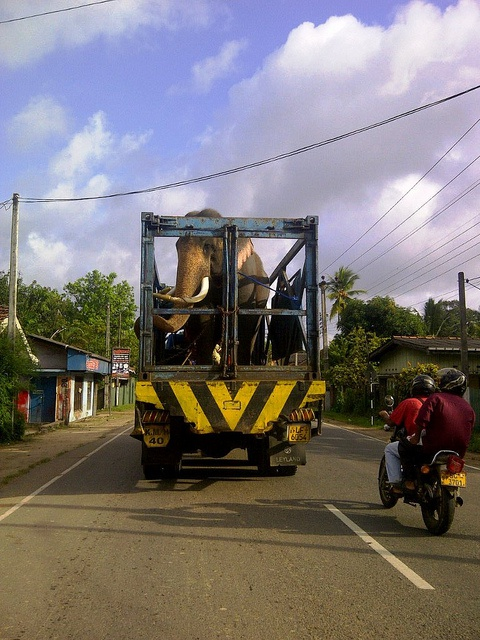Describe the objects in this image and their specific colors. I can see truck in darkgray, black, gray, and olive tones, elephant in darkgray, black, maroon, and gray tones, people in darkgray, black, maroon, gray, and darkgreen tones, motorcycle in darkgray, black, maroon, olive, and gray tones, and people in darkgray, black, maroon, brown, and gray tones in this image. 